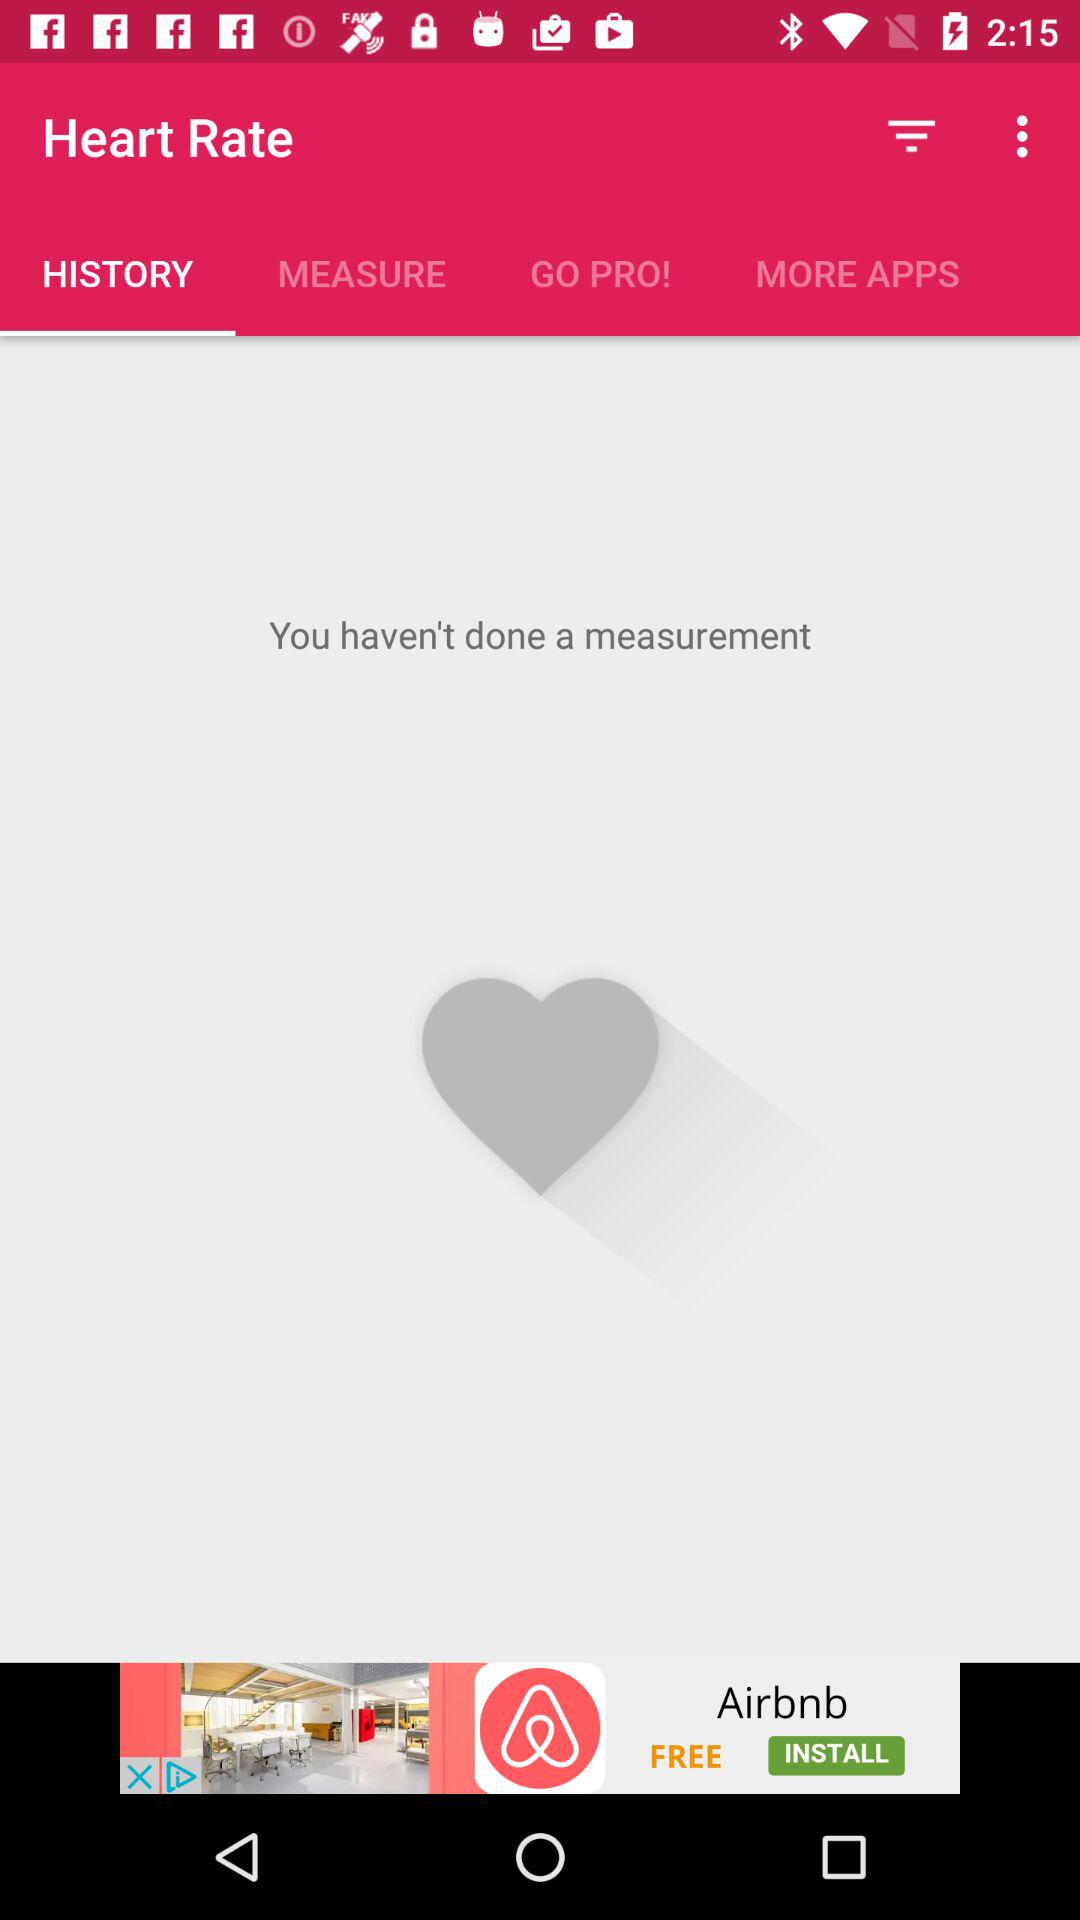Which tab is selected? The selected tab is "HISTORY". 